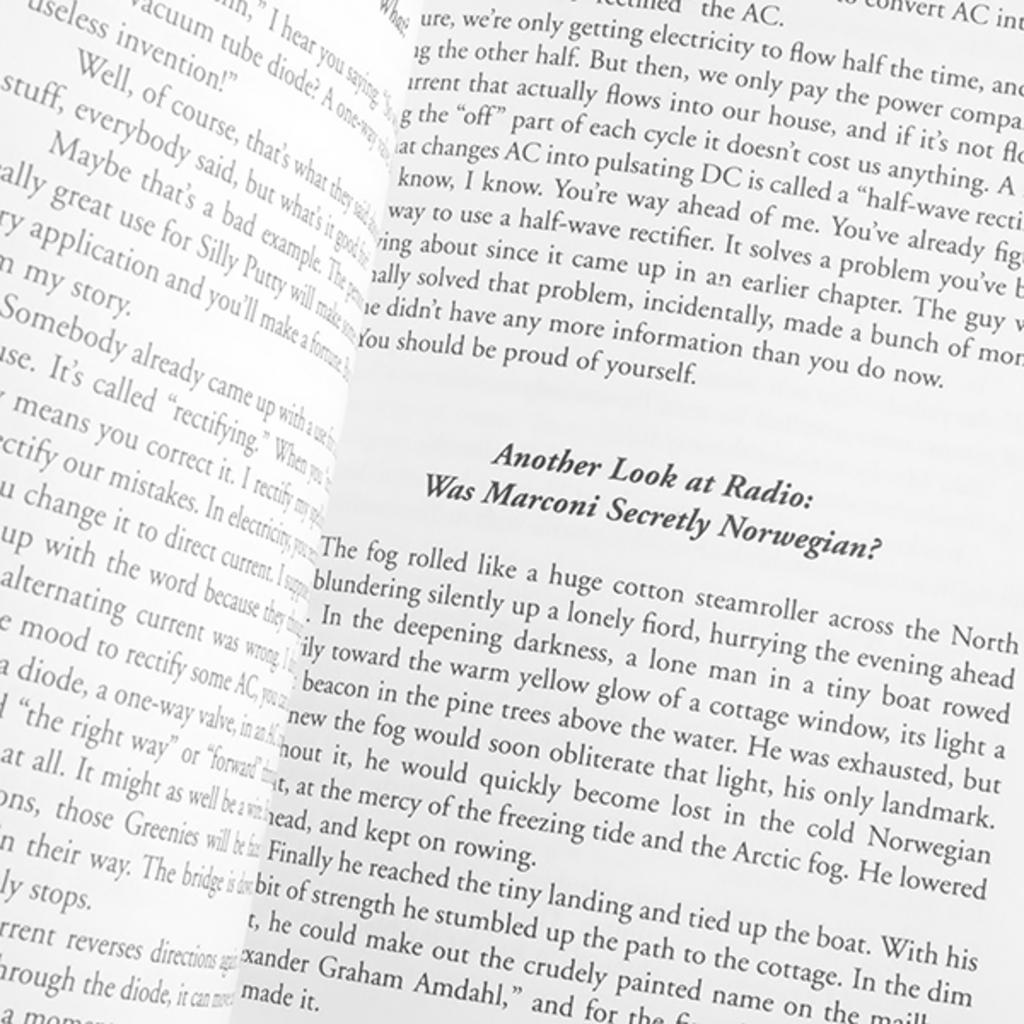Provide a one-sentence caption for the provided image. A book about Marconi and radio, open to questions about Marconi's heritage. 